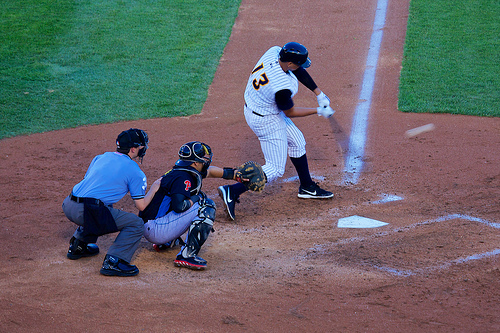Is the umpire wearing a shield? Yes, for protection, the umpire behind the catcher wears a chest shield. 